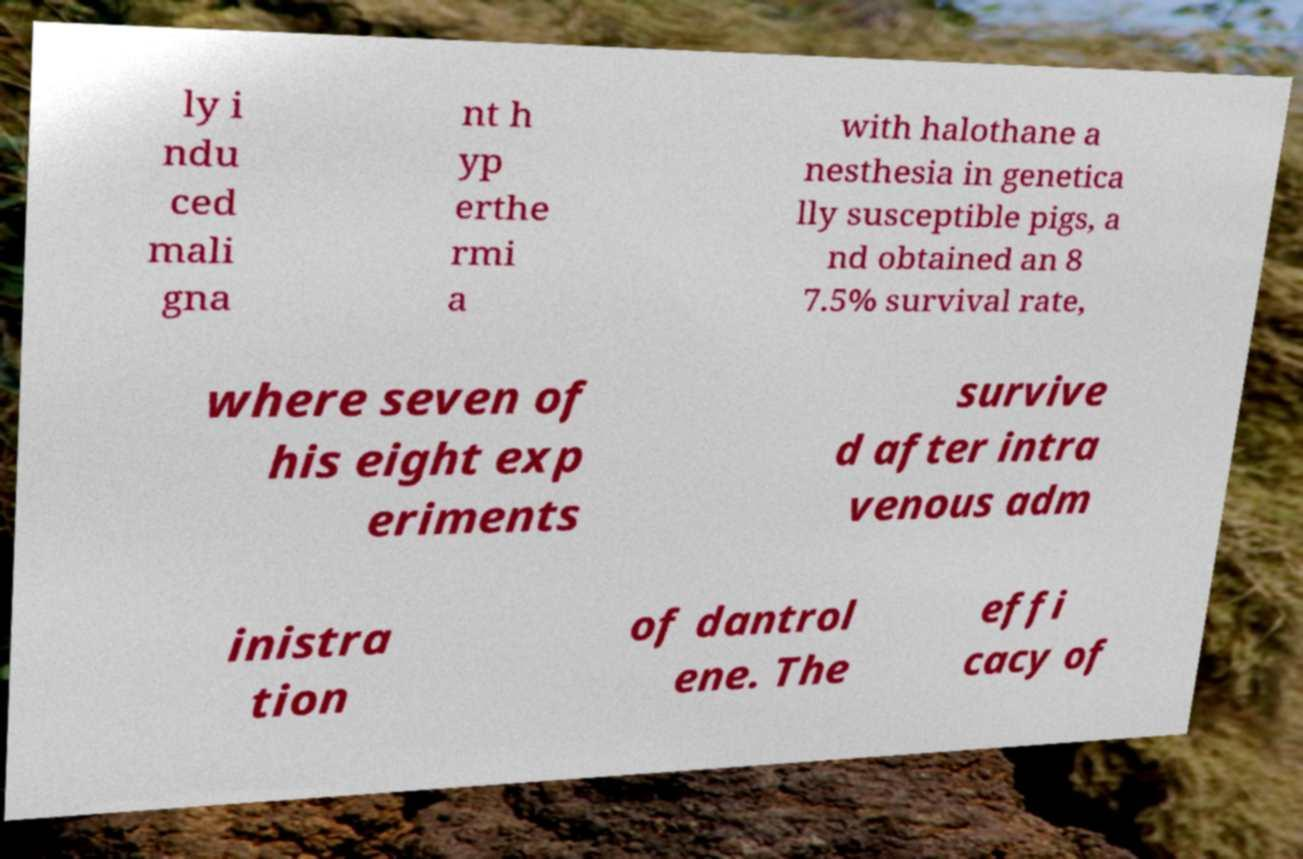Please identify and transcribe the text found in this image. ly i ndu ced mali gna nt h yp erthe rmi a with halothane a nesthesia in genetica lly susceptible pigs, a nd obtained an 8 7.5% survival rate, where seven of his eight exp eriments survive d after intra venous adm inistra tion of dantrol ene. The effi cacy of 